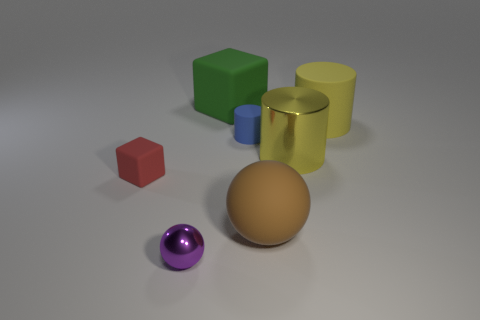Is the number of large matte objects to the left of the yellow metallic object greater than the number of small cubes?
Your response must be concise. Yes. The tiny object that is on the left side of the small metal object is what color?
Provide a succinct answer. Red. The rubber thing that is the same color as the large metal cylinder is what size?
Ensure brevity in your answer.  Large. How many rubber objects are either big brown things or tiny brown balls?
Provide a short and direct response. 1. Is there a big yellow object on the left side of the matte cylinder right of the large cylinder that is in front of the tiny blue object?
Your response must be concise. Yes. There is a purple object; how many small matte blocks are right of it?
Give a very brief answer. 0. What is the material of the cylinder that is the same color as the big shiny object?
Make the answer very short. Rubber. How many small things are purple shiny things or rubber blocks?
Keep it short and to the point. 2. What is the shape of the big yellow thing that is left of the large rubber cylinder?
Your response must be concise. Cylinder. Is there another cylinder of the same color as the big rubber cylinder?
Provide a succinct answer. Yes. 